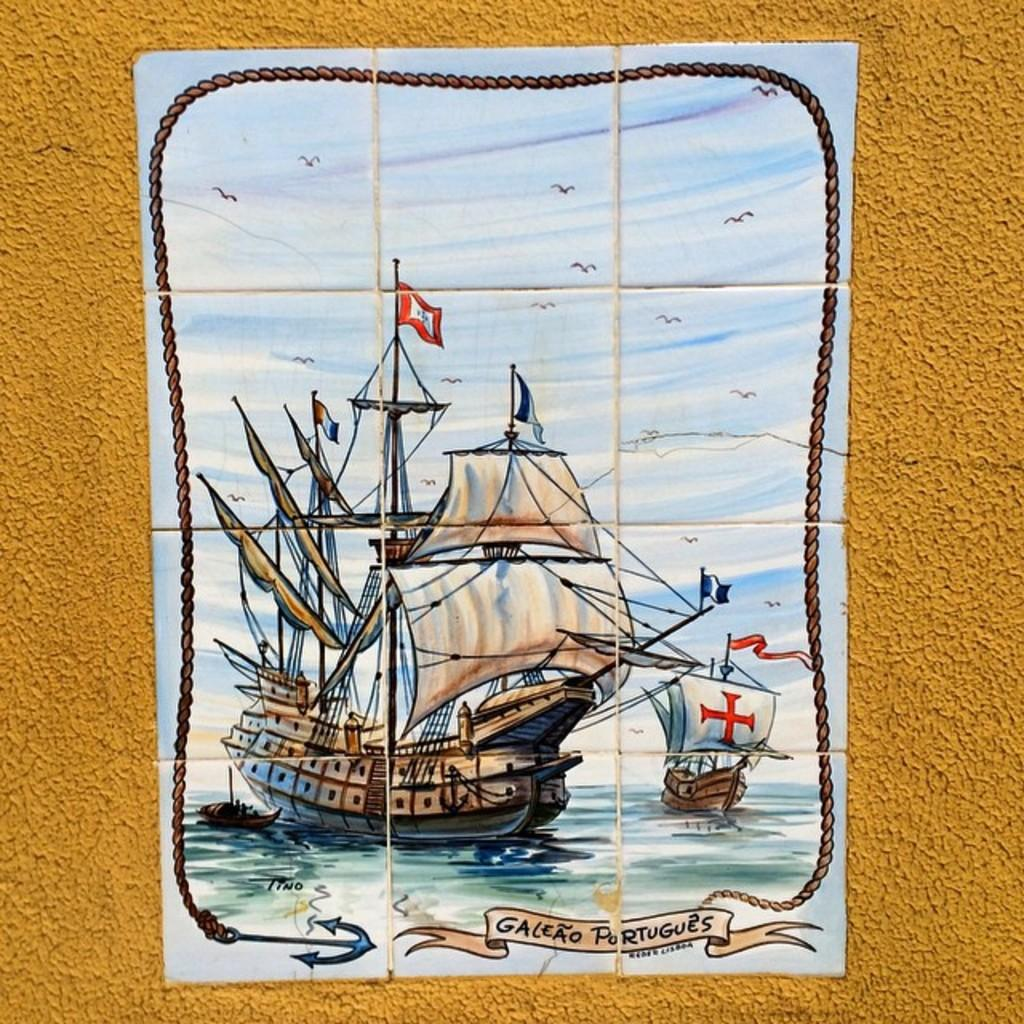<image>
Describe the image concisely. A drawing of a ship that was drawn by the artist Tino. 